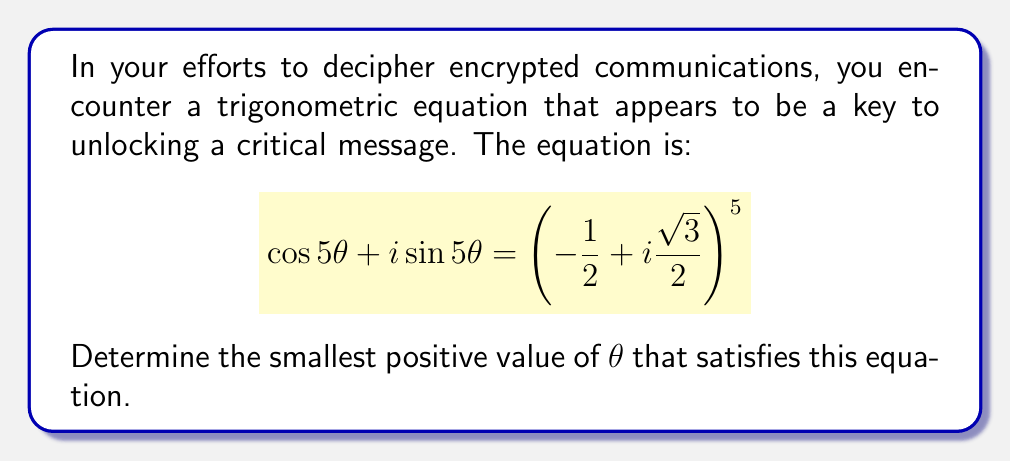What is the answer to this math problem? Let's approach this step-by-step using De Moivre's theorem:

1) First, recall De Moivre's theorem: For any real number $x$ and integer $n$,
   $$(cos x + i \sin x)^n = \cos(nx) + i \sin(nx)$$

2) The left side of our equation, $\cos 5\theta + i \sin 5\theta$, is already in the form of the right side of De Moivre's theorem.

3) The right side of our equation, $(-\frac{1}{2} + i\frac{\sqrt{3}}{2})^5$, can be written as $(\cos \frac{2\pi}{3} + i \sin \frac{2\pi}{3})^5$ because $\cos \frac{2\pi}{3} = -\frac{1}{2}$ and $\sin \frac{2\pi}{3} = \frac{\sqrt{3}}{2}$.

4) Applying De Moivre's theorem to the right side:
   $$(\cos \frac{2\pi}{3} + i \sin \frac{2\pi}{3})^5 = \cos(\frac{10\pi}{3}) + i \sin(\frac{10\pi}{3})$$

5) Now our equation looks like:
   $$\cos 5\theta + i \sin 5\theta = \cos(\frac{10\pi}{3}) + i \sin(\frac{10\pi}{3})$$

6) For this equality to hold, the arguments must be equal (possibly differing by multiples of $2\pi$):
   $$5\theta = \frac{10\pi}{3} + 2\pi k, \quad \text{where } k \text{ is an integer}$$

7) Solving for $\theta$:
   $$\theta = \frac{2\pi}{3} + \frac{2\pi k}{5}$$

8) The smallest positive value of $\theta$ occurs when $k = 0$:
   $$\theta = \frac{2\pi}{3} = \frac{\pi}{3} \cdot 2 \approx 2.0944 \text{ radians}$$
Answer: $\frac{2\pi}{3}$ radians 